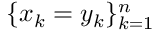<formula> <loc_0><loc_0><loc_500><loc_500>\{ x _ { k } = y _ { k } \} _ { k = 1 } ^ { n }</formula> 